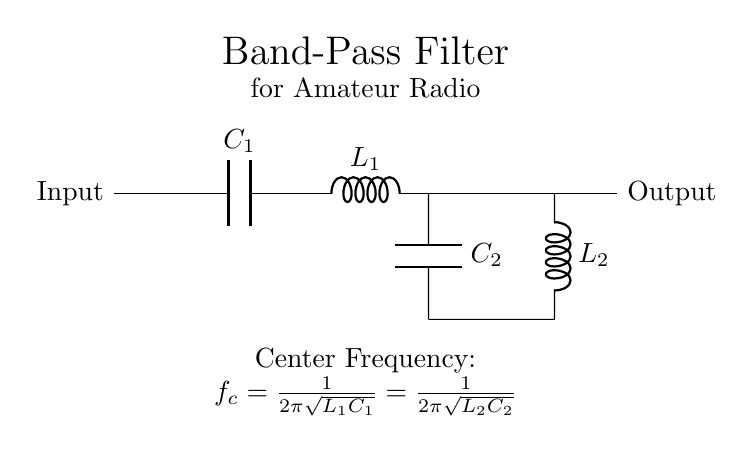What type of filter is shown in the diagram? The diagram depicts a band-pass filter, which is specifically designed to allow frequencies within a certain range while attenuating frequencies outside that range. This can be identified from the arrangement of components that are typical of a band-pass configuration.
Answer: Band-pass filter What components are used in the filter circuit? The components used in this filter circuit include two capacitors (labeled C1 and C2) and two inductors (labeled L1 and L2). The specific configuration of these components allows for the band-pass characteristic.
Answer: Two capacitors and two inductors What is the center frequency formula for this filter? The center frequency (f_c) is described as f_c = 1 over 2π times the square root of L1C1, which is also equal to 1 over 2π times the square root of L2C2. This formula indicates that the center frequency is determined by the values of the inductors and capacitors.
Answer: f_c = 1 over 2π times the square root of L1C1 = 1 over 2π times the square root of L2C2 How many branches are in the circuit? The circuit consists of three main branches: one for the series LC combination (C1 and L1) and one for the parallel LC combination (C2 and L2), along with the input and output paths. Understanding the layout reveals the different signal paths.
Answer: Three branches Why are there two LC networks in the filter? The presence of both a series LC circuit (C1 and L1) and a parallel LC circuit (C2 and L2) allows the filter to create a wide band-pass behavior. The series circuit selects a certain frequency range, while the parallel circuit serves to further refine the selected frequencies, enhancing selectivity.
Answer: To create a wide band-pass behavior What is the role of the capacitors in the filter? The capacitors in the filter (C1 and C2) serve to control the frequency response of the circuit. They affect the impedance characteristics of the filter, shaping the passband and influencing how signals of different frequencies are attenuated or allowed to pass.
Answer: To control the frequency response 